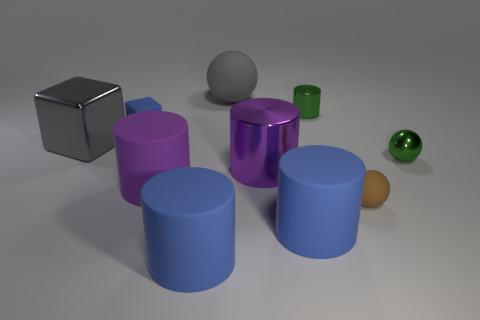What is the shape of the object that is the same color as the big metallic block?
Provide a succinct answer. Sphere. What size is the other cylinder that is the same color as the big metal cylinder?
Ensure brevity in your answer.  Large. Are there more large gray rubber things than big brown metal blocks?
Provide a short and direct response. Yes. There is a metallic object to the left of the large gray rubber object; is it the same color as the big ball?
Offer a very short reply. Yes. What number of objects are either brown rubber objects in front of the metal ball or spheres that are on the right side of the big gray rubber ball?
Offer a very short reply. 2. How many things are to the left of the big purple metal object and right of the tiny block?
Give a very brief answer. 3. Does the green cylinder have the same material as the tiny green sphere?
Your response must be concise. Yes. The blue thing behind the ball that is in front of the large metallic thing on the right side of the large purple matte cylinder is what shape?
Keep it short and to the point. Cube. There is a big cylinder that is both right of the big sphere and in front of the small brown matte object; what material is it?
Provide a short and direct response. Rubber. There is a large metal thing that is in front of the metal cube to the left of the big gray rubber object that is on the left side of the large metal cylinder; what color is it?
Your answer should be very brief. Purple. 